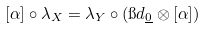Convert formula to latex. <formula><loc_0><loc_0><loc_500><loc_500>[ \alpha ] \circ \lambda _ { X } = \lambda _ { Y } \circ ( \i d _ { \underline { 0 } } \otimes [ \alpha ] )</formula> 